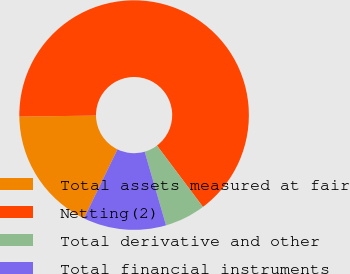Convert chart to OTSL. <chart><loc_0><loc_0><loc_500><loc_500><pie_chart><fcel>Total assets measured at fair<fcel>Netting(2)<fcel>Total derivative and other<fcel>Total financial instruments<nl><fcel>17.6%<fcel>64.97%<fcel>5.75%<fcel>11.68%<nl></chart> 